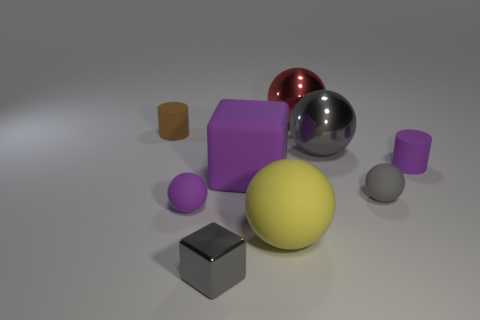Subtract 2 spheres. How many spheres are left? 3 Subtract all yellow spheres. How many spheres are left? 4 Subtract all green balls. Subtract all red cubes. How many balls are left? 5 Add 1 large red metal cylinders. How many objects exist? 10 Subtract all spheres. How many objects are left? 4 Add 7 gray spheres. How many gray spheres are left? 9 Add 4 brown matte cylinders. How many brown matte cylinders exist? 5 Subtract 1 purple blocks. How many objects are left? 8 Subtract all large blue blocks. Subtract all matte cylinders. How many objects are left? 7 